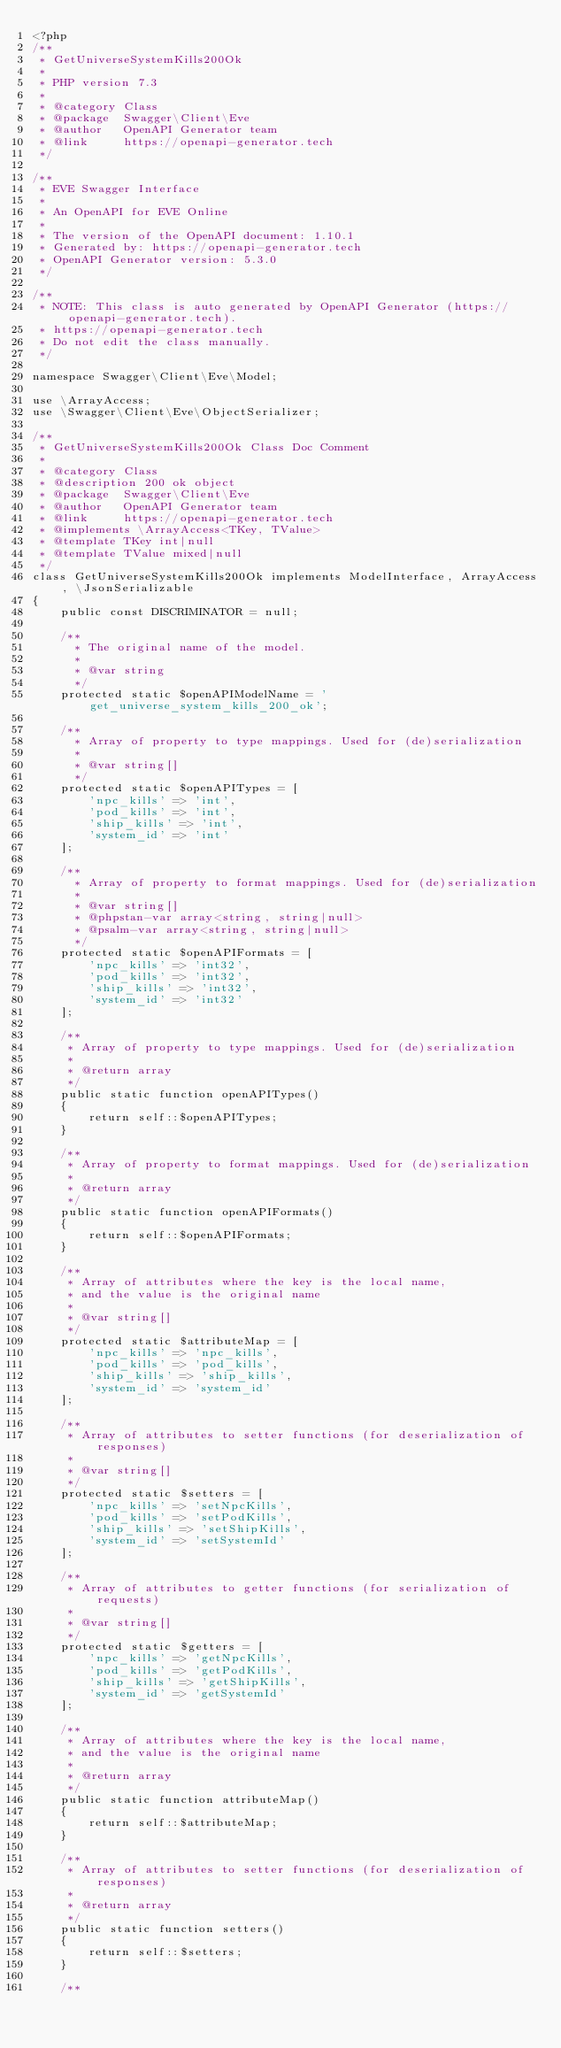Convert code to text. <code><loc_0><loc_0><loc_500><loc_500><_PHP_><?php
/**
 * GetUniverseSystemKills200Ok
 *
 * PHP version 7.3
 *
 * @category Class
 * @package  Swagger\Client\Eve
 * @author   OpenAPI Generator team
 * @link     https://openapi-generator.tech
 */

/**
 * EVE Swagger Interface
 *
 * An OpenAPI for EVE Online
 *
 * The version of the OpenAPI document: 1.10.1
 * Generated by: https://openapi-generator.tech
 * OpenAPI Generator version: 5.3.0
 */

/**
 * NOTE: This class is auto generated by OpenAPI Generator (https://openapi-generator.tech).
 * https://openapi-generator.tech
 * Do not edit the class manually.
 */

namespace Swagger\Client\Eve\Model;

use \ArrayAccess;
use \Swagger\Client\Eve\ObjectSerializer;

/**
 * GetUniverseSystemKills200Ok Class Doc Comment
 *
 * @category Class
 * @description 200 ok object
 * @package  Swagger\Client\Eve
 * @author   OpenAPI Generator team
 * @link     https://openapi-generator.tech
 * @implements \ArrayAccess<TKey, TValue>
 * @template TKey int|null
 * @template TValue mixed|null
 */
class GetUniverseSystemKills200Ok implements ModelInterface, ArrayAccess, \JsonSerializable
{
    public const DISCRIMINATOR = null;

    /**
      * The original name of the model.
      *
      * @var string
      */
    protected static $openAPIModelName = 'get_universe_system_kills_200_ok';

    /**
      * Array of property to type mappings. Used for (de)serialization
      *
      * @var string[]
      */
    protected static $openAPITypes = [
        'npc_kills' => 'int',
        'pod_kills' => 'int',
        'ship_kills' => 'int',
        'system_id' => 'int'
    ];

    /**
      * Array of property to format mappings. Used for (de)serialization
      *
      * @var string[]
      * @phpstan-var array<string, string|null>
      * @psalm-var array<string, string|null>
      */
    protected static $openAPIFormats = [
        'npc_kills' => 'int32',
        'pod_kills' => 'int32',
        'ship_kills' => 'int32',
        'system_id' => 'int32'
    ];

    /**
     * Array of property to type mappings. Used for (de)serialization
     *
     * @return array
     */
    public static function openAPITypes()
    {
        return self::$openAPITypes;
    }

    /**
     * Array of property to format mappings. Used for (de)serialization
     *
     * @return array
     */
    public static function openAPIFormats()
    {
        return self::$openAPIFormats;
    }

    /**
     * Array of attributes where the key is the local name,
     * and the value is the original name
     *
     * @var string[]
     */
    protected static $attributeMap = [
        'npc_kills' => 'npc_kills',
        'pod_kills' => 'pod_kills',
        'ship_kills' => 'ship_kills',
        'system_id' => 'system_id'
    ];

    /**
     * Array of attributes to setter functions (for deserialization of responses)
     *
     * @var string[]
     */
    protected static $setters = [
        'npc_kills' => 'setNpcKills',
        'pod_kills' => 'setPodKills',
        'ship_kills' => 'setShipKills',
        'system_id' => 'setSystemId'
    ];

    /**
     * Array of attributes to getter functions (for serialization of requests)
     *
     * @var string[]
     */
    protected static $getters = [
        'npc_kills' => 'getNpcKills',
        'pod_kills' => 'getPodKills',
        'ship_kills' => 'getShipKills',
        'system_id' => 'getSystemId'
    ];

    /**
     * Array of attributes where the key is the local name,
     * and the value is the original name
     *
     * @return array
     */
    public static function attributeMap()
    {
        return self::$attributeMap;
    }

    /**
     * Array of attributes to setter functions (for deserialization of responses)
     *
     * @return array
     */
    public static function setters()
    {
        return self::$setters;
    }

    /**</code> 